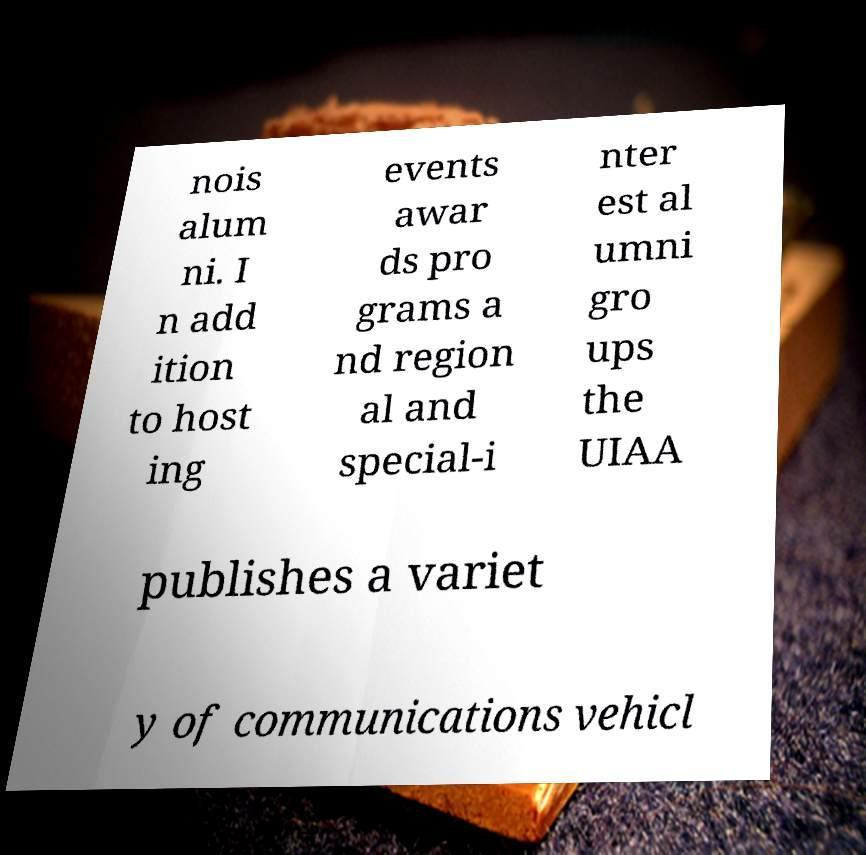Please read and relay the text visible in this image. What does it say? nois alum ni. I n add ition to host ing events awar ds pro grams a nd region al and special-i nter est al umni gro ups the UIAA publishes a variet y of communications vehicl 